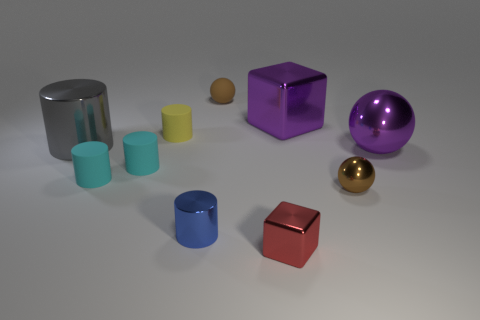There is another big object that is the same shape as the yellow object; what is it made of?
Ensure brevity in your answer.  Metal. The shiny object that is on the left side of the tiny red metal cube and to the right of the gray metallic object is what color?
Your answer should be very brief. Blue. The big sphere has what color?
Make the answer very short. Purple. There is a ball that is the same color as the big shiny block; what is it made of?
Give a very brief answer. Metal. Is there a small blue object of the same shape as the small brown metallic thing?
Make the answer very short. No. There is a brown sphere behind the tiny brown metal ball; how big is it?
Your answer should be compact. Small. There is a blue cylinder that is the same size as the brown metal sphere; what is its material?
Your answer should be very brief. Metal. Is the number of large gray things greater than the number of small cylinders?
Give a very brief answer. No. What is the size of the metallic cube that is behind the big object that is on the left side of the matte ball?
Make the answer very short. Large. There is a red metal thing that is the same size as the yellow matte cylinder; what is its shape?
Offer a very short reply. Cube. 